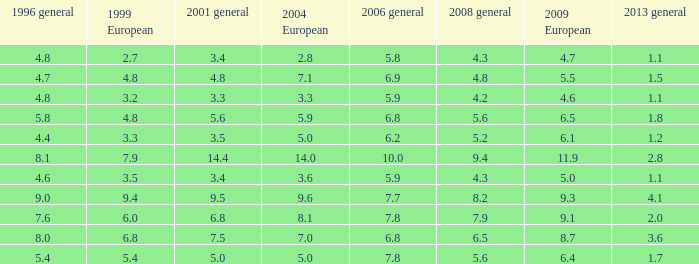Parse the full table. {'header': ['1996 general', '1999 European', '2001 general', '2004 European', '2006 general', '2008 general', '2009 European', '2013 general'], 'rows': [['4.8', '2.7', '3.4', '2.8', '5.8', '4.3', '4.7', '1.1'], ['4.7', '4.8', '4.8', '7.1', '6.9', '4.8', '5.5', '1.5'], ['4.8', '3.2', '3.3', '3.3', '5.9', '4.2', '4.6', '1.1'], ['5.8', '4.8', '5.6', '5.9', '6.8', '5.6', '6.5', '1.8'], ['4.4', '3.3', '3.5', '5.0', '6.2', '5.2', '6.1', '1.2'], ['8.1', '7.9', '14.4', '14.0', '10.0', '9.4', '11.9', '2.8'], ['4.6', '3.5', '3.4', '3.6', '5.9', '4.3', '5.0', '1.1'], ['9.0', '9.4', '9.5', '9.6', '7.7', '8.2', '9.3', '4.1'], ['7.6', '6.0', '6.8', '8.1', '7.8', '7.9', '9.1', '2.0'], ['8.0', '6.8', '7.5', '7.0', '6.8', '6.5', '8.7', '3.6'], ['5.4', '5.4', '5.0', '5.0', '7.8', '5.6', '6.4', '1.7']]} What was the value for 2004 European with less than 7.5 in general 2001, less than 6.4 in 2009 European, and less than 1.5 in general 2013 with 4.3 in 2008 general? 3.6, 2.8. 